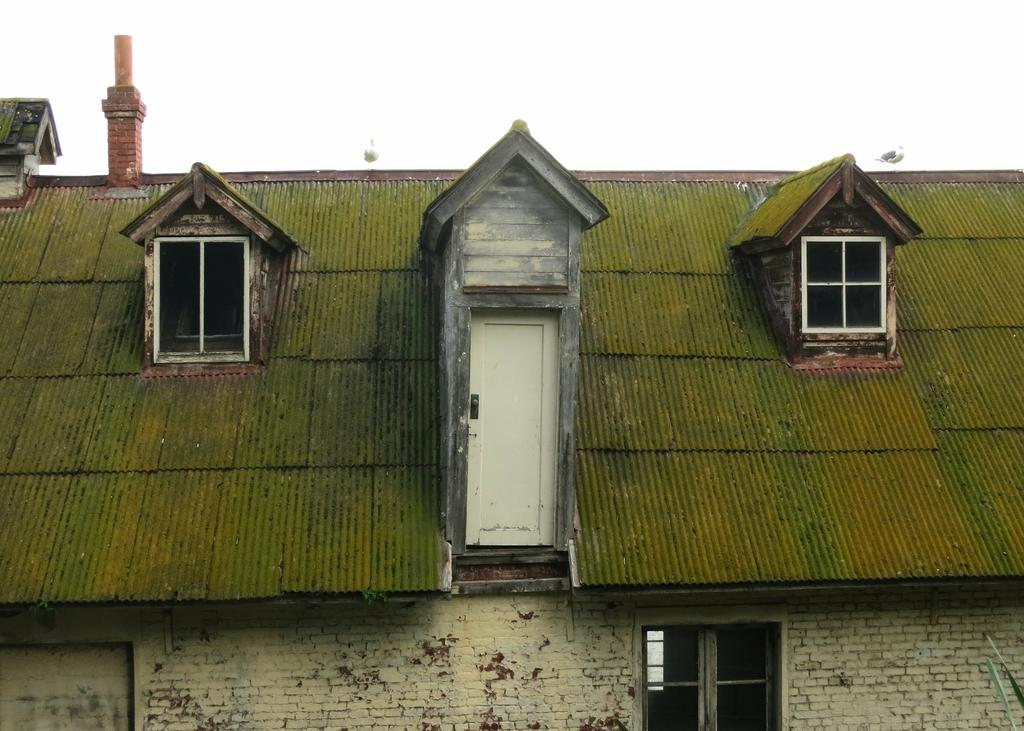What type of structure is visible in the image? There is a house in the image. Can you describe a specific feature of the house? There is a door in the middle of the image. What type of pen is being used to draw the house in the image? There is no pen present in the image, as it is a photograph of a real house. 